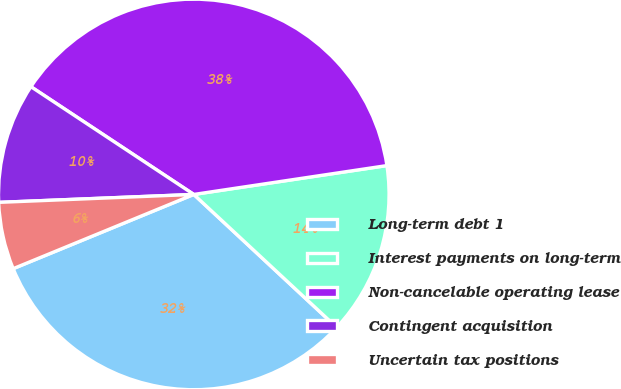Convert chart to OTSL. <chart><loc_0><loc_0><loc_500><loc_500><pie_chart><fcel>Long-term debt 1<fcel>Interest payments on long-term<fcel>Non-cancelable operating lease<fcel>Contingent acquisition<fcel>Uncertain tax positions<nl><fcel>31.87%<fcel>14.29%<fcel>38.34%<fcel>9.95%<fcel>5.56%<nl></chart> 